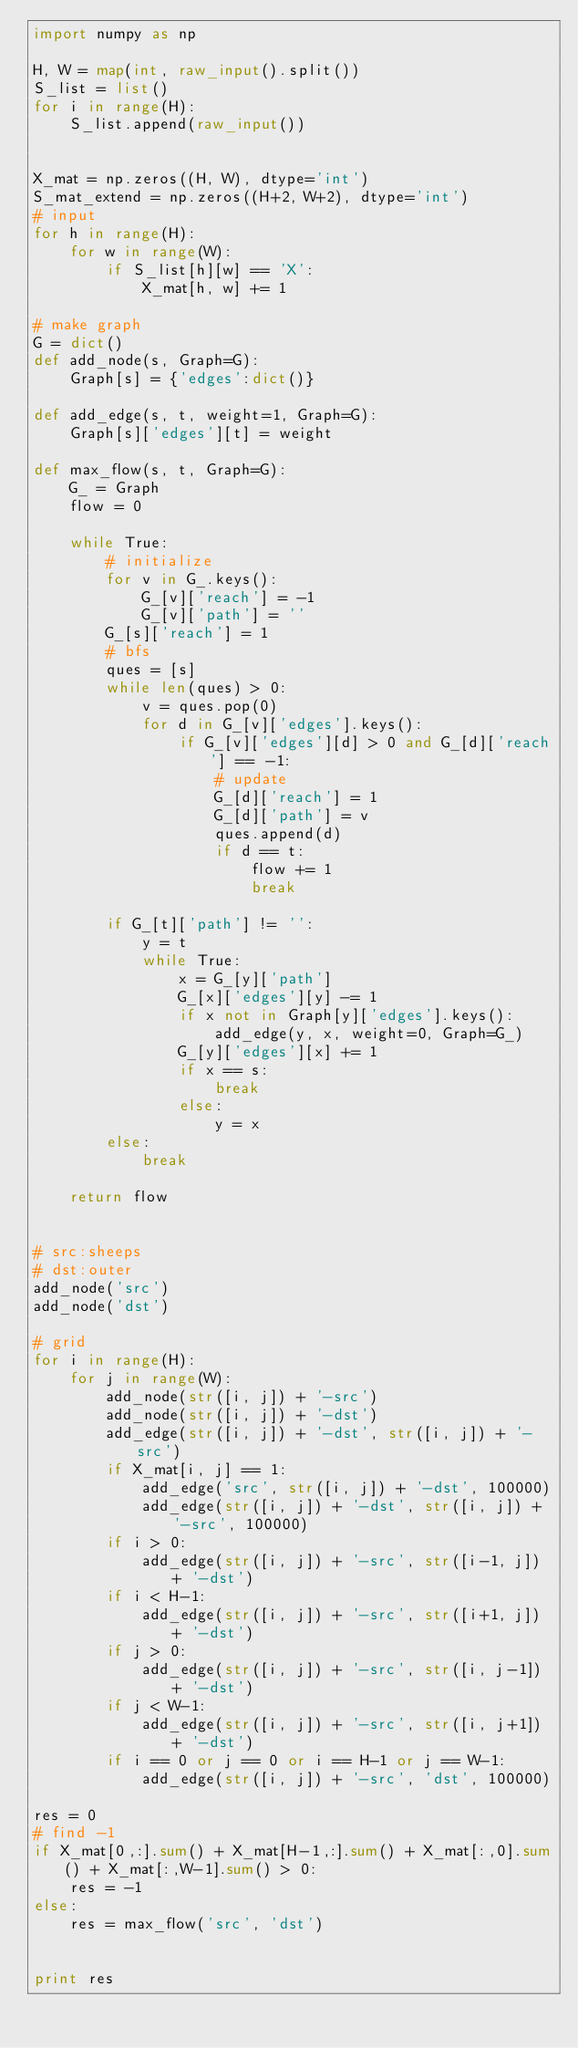Convert code to text. <code><loc_0><loc_0><loc_500><loc_500><_Python_>import numpy as np

H, W = map(int, raw_input().split())
S_list = list()
for i in range(H):
    S_list.append(raw_input())


X_mat = np.zeros((H, W), dtype='int')
S_mat_extend = np.zeros((H+2, W+2), dtype='int')
# input
for h in range(H):
    for w in range(W):
        if S_list[h][w] == 'X':
            X_mat[h, w] += 1

# make graph
G = dict()
def add_node(s, Graph=G):
    Graph[s] = {'edges':dict()}
    
def add_edge(s, t, weight=1, Graph=G):
    Graph[s]['edges'][t] = weight

def max_flow(s, t, Graph=G):
    G_ = Graph
    flow = 0
    
    while True:
        # initialize
        for v in G_.keys():
            G_[v]['reach'] = -1
            G_[v]['path'] = ''
        G_[s]['reach'] = 1
        # bfs
        ques = [s]
        while len(ques) > 0:
            v = ques.pop(0)
            for d in G_[v]['edges'].keys():
                if G_[v]['edges'][d] > 0 and G_[d]['reach'] == -1:
                    # update
                    G_[d]['reach'] = 1
                    G_[d]['path'] = v
                    ques.append(d)
                    if d == t:
                        flow += 1
                        break

        if G_[t]['path'] != '':
            y = t
            while True:
                x = G_[y]['path']
                G_[x]['edges'][y] -= 1
                if x not in Graph[y]['edges'].keys():
                    add_edge(y, x, weight=0, Graph=G_)
                G_[y]['edges'][x] += 1
                if x == s:
                    break
                else:
                    y = x
        else:
            break
    
    return flow


# src:sheeps
# dst:outer
add_node('src')
add_node('dst')

# grid
for i in range(H):
    for j in range(W):
        add_node(str([i, j]) + '-src')
        add_node(str([i, j]) + '-dst')
        add_edge(str([i, j]) + '-dst', str([i, j]) + '-src')
        if X_mat[i, j] == 1:
            add_edge('src', str([i, j]) + '-dst', 100000)
            add_edge(str([i, j]) + '-dst', str([i, j]) + '-src', 100000)
        if i > 0:
            add_edge(str([i, j]) + '-src', str([i-1, j]) + '-dst')
        if i < H-1:
            add_edge(str([i, j]) + '-src', str([i+1, j]) + '-dst')
        if j > 0:
            add_edge(str([i, j]) + '-src', str([i, j-1]) + '-dst')
        if j < W-1:
            add_edge(str([i, j]) + '-src', str([i, j+1]) + '-dst')
        if i == 0 or j == 0 or i == H-1 or j == W-1:
            add_edge(str([i, j]) + '-src', 'dst', 100000)

res = 0
# find -1
if X_mat[0,:].sum() + X_mat[H-1,:].sum() + X_mat[:,0].sum() + X_mat[:,W-1].sum() > 0:
    res = -1
else:
    res = max_flow('src', 'dst')


print res</code> 